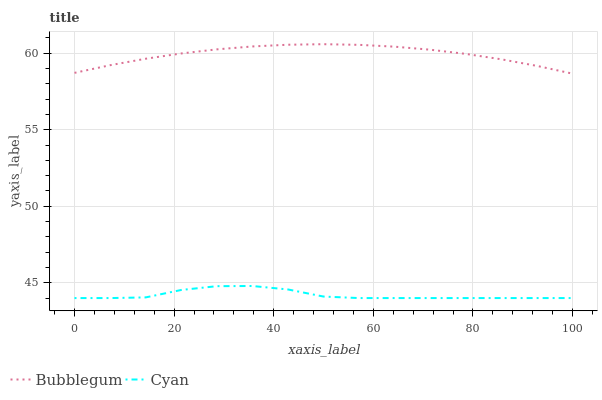Does Cyan have the minimum area under the curve?
Answer yes or no. Yes. Does Bubblegum have the maximum area under the curve?
Answer yes or no. Yes. Does Bubblegum have the minimum area under the curve?
Answer yes or no. No. Is Bubblegum the smoothest?
Answer yes or no. Yes. Is Cyan the roughest?
Answer yes or no. Yes. Is Bubblegum the roughest?
Answer yes or no. No. Does Cyan have the lowest value?
Answer yes or no. Yes. Does Bubblegum have the lowest value?
Answer yes or no. No. Does Bubblegum have the highest value?
Answer yes or no. Yes. Is Cyan less than Bubblegum?
Answer yes or no. Yes. Is Bubblegum greater than Cyan?
Answer yes or no. Yes. Does Cyan intersect Bubblegum?
Answer yes or no. No. 